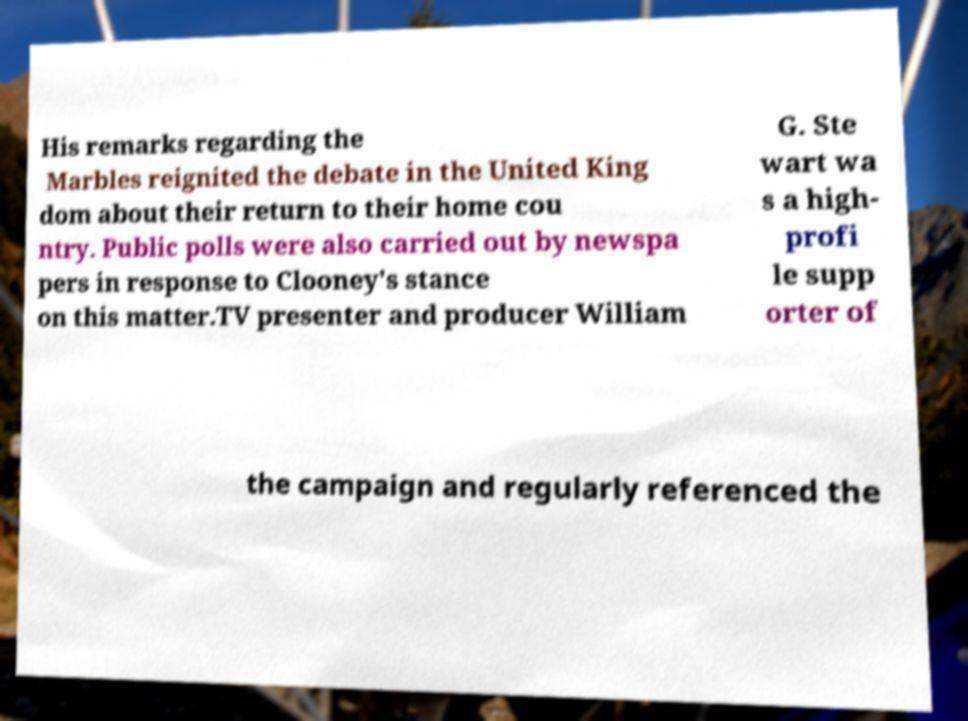There's text embedded in this image that I need extracted. Can you transcribe it verbatim? His remarks regarding the Marbles reignited the debate in the United King dom about their return to their home cou ntry. Public polls were also carried out by newspa pers in response to Clooney's stance on this matter.TV presenter and producer William G. Ste wart wa s a high- profi le supp orter of the campaign and regularly referenced the 